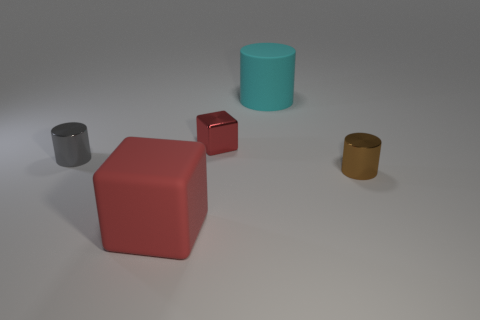Add 5 large red cubes. How many objects exist? 10 Subtract all cubes. How many objects are left? 3 Subtract all tiny cylinders. Subtract all gray shiny objects. How many objects are left? 2 Add 1 small metal blocks. How many small metal blocks are left? 2 Add 4 gray metallic cylinders. How many gray metallic cylinders exist? 5 Subtract 0 brown balls. How many objects are left? 5 